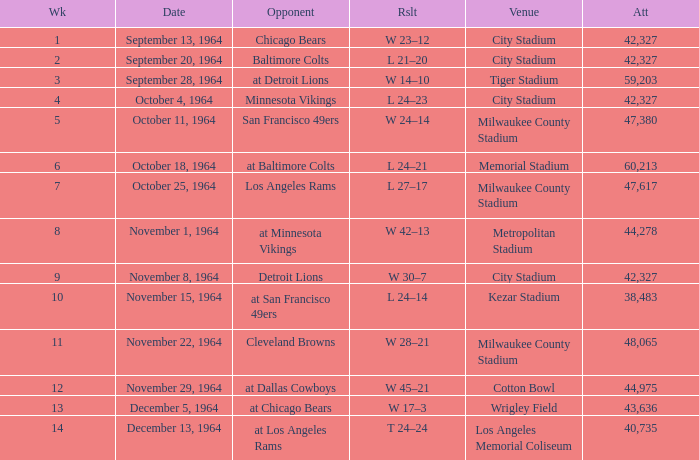What venue held that game with a result of l 24–14? Kezar Stadium. Could you parse the entire table? {'header': ['Wk', 'Date', 'Opponent', 'Rslt', 'Venue', 'Att'], 'rows': [['1', 'September 13, 1964', 'Chicago Bears', 'W 23–12', 'City Stadium', '42,327'], ['2', 'September 20, 1964', 'Baltimore Colts', 'L 21–20', 'City Stadium', '42,327'], ['3', 'September 28, 1964', 'at Detroit Lions', 'W 14–10', 'Tiger Stadium', '59,203'], ['4', 'October 4, 1964', 'Minnesota Vikings', 'L 24–23', 'City Stadium', '42,327'], ['5', 'October 11, 1964', 'San Francisco 49ers', 'W 24–14', 'Milwaukee County Stadium', '47,380'], ['6', 'October 18, 1964', 'at Baltimore Colts', 'L 24–21', 'Memorial Stadium', '60,213'], ['7', 'October 25, 1964', 'Los Angeles Rams', 'L 27–17', 'Milwaukee County Stadium', '47,617'], ['8', 'November 1, 1964', 'at Minnesota Vikings', 'W 42–13', 'Metropolitan Stadium', '44,278'], ['9', 'November 8, 1964', 'Detroit Lions', 'W 30–7', 'City Stadium', '42,327'], ['10', 'November 15, 1964', 'at San Francisco 49ers', 'L 24–14', 'Kezar Stadium', '38,483'], ['11', 'November 22, 1964', 'Cleveland Browns', 'W 28–21', 'Milwaukee County Stadium', '48,065'], ['12', 'November 29, 1964', 'at Dallas Cowboys', 'W 45–21', 'Cotton Bowl', '44,975'], ['13', 'December 5, 1964', 'at Chicago Bears', 'W 17–3', 'Wrigley Field', '43,636'], ['14', 'December 13, 1964', 'at Los Angeles Rams', 'T 24–24', 'Los Angeles Memorial Coliseum', '40,735']]} 